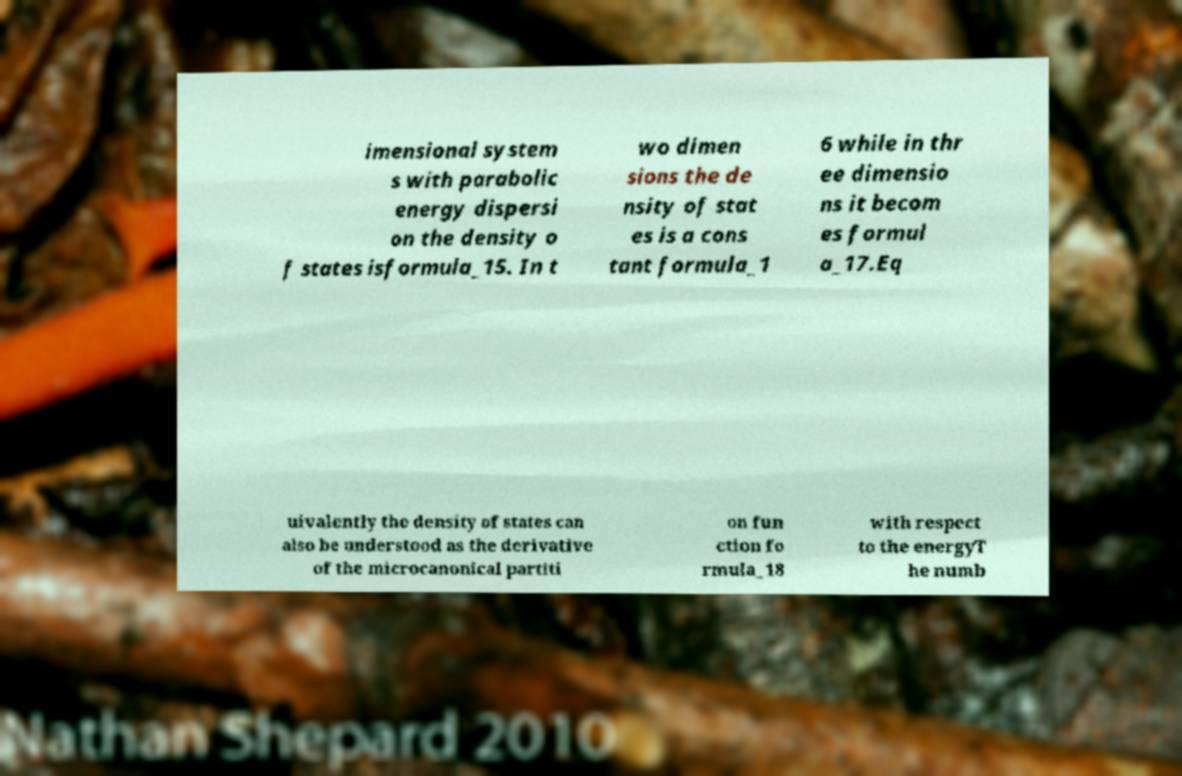Can you accurately transcribe the text from the provided image for me? imensional system s with parabolic energy dispersi on the density o f states isformula_15. In t wo dimen sions the de nsity of stat es is a cons tant formula_1 6 while in thr ee dimensio ns it becom es formul a_17.Eq uivalently the density of states can also be understood as the derivative of the microcanonical partiti on fun ction fo rmula_18 with respect to the energyT he numb 